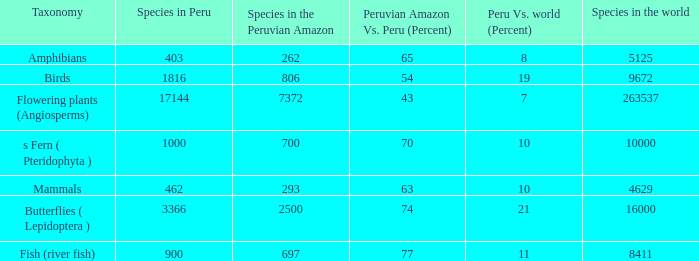What's the total number of species in the peruvian amazon with 8411 species in the world  1.0. 